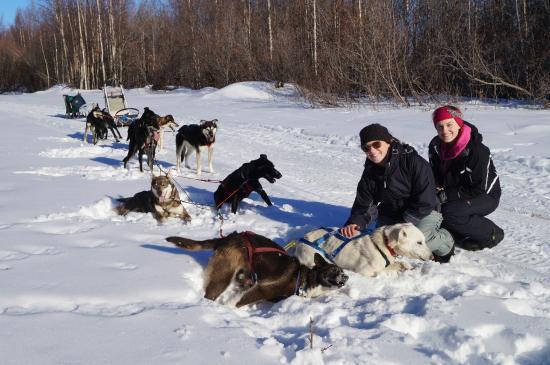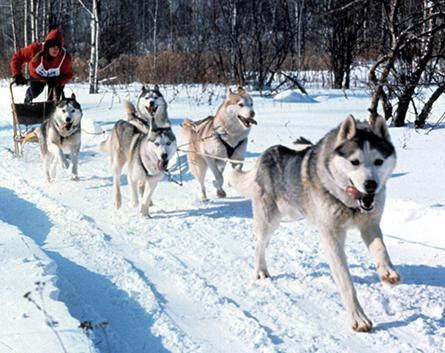The first image is the image on the left, the second image is the image on the right. For the images shown, is this caption "There are exactly two people in the image on the left." true? Answer yes or no. Yes. 